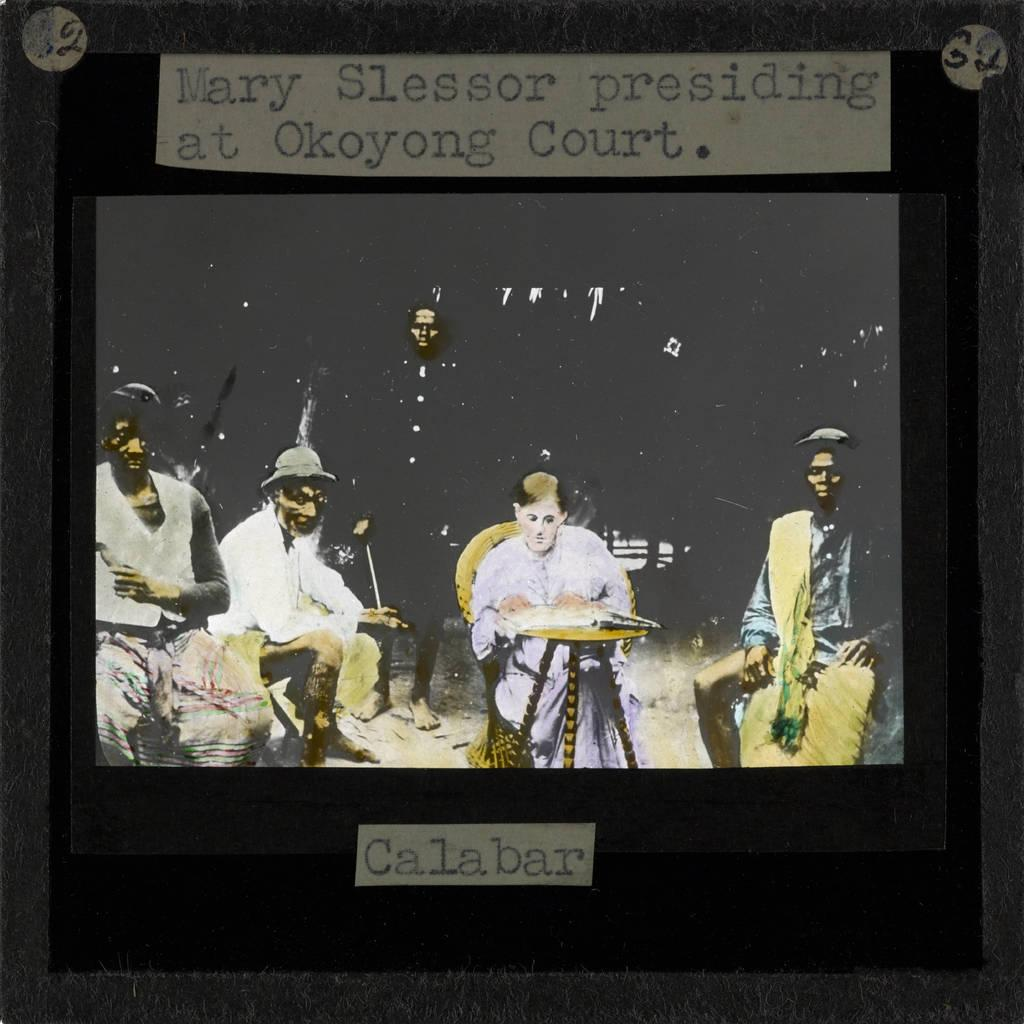Who or what can be seen in the image? There are people depicted in the image. Are there any objects with writing in the image? Yes, there is writing on objects in the image. How does the servant kick the ball in the image? There is no servant or ball present in the image. 